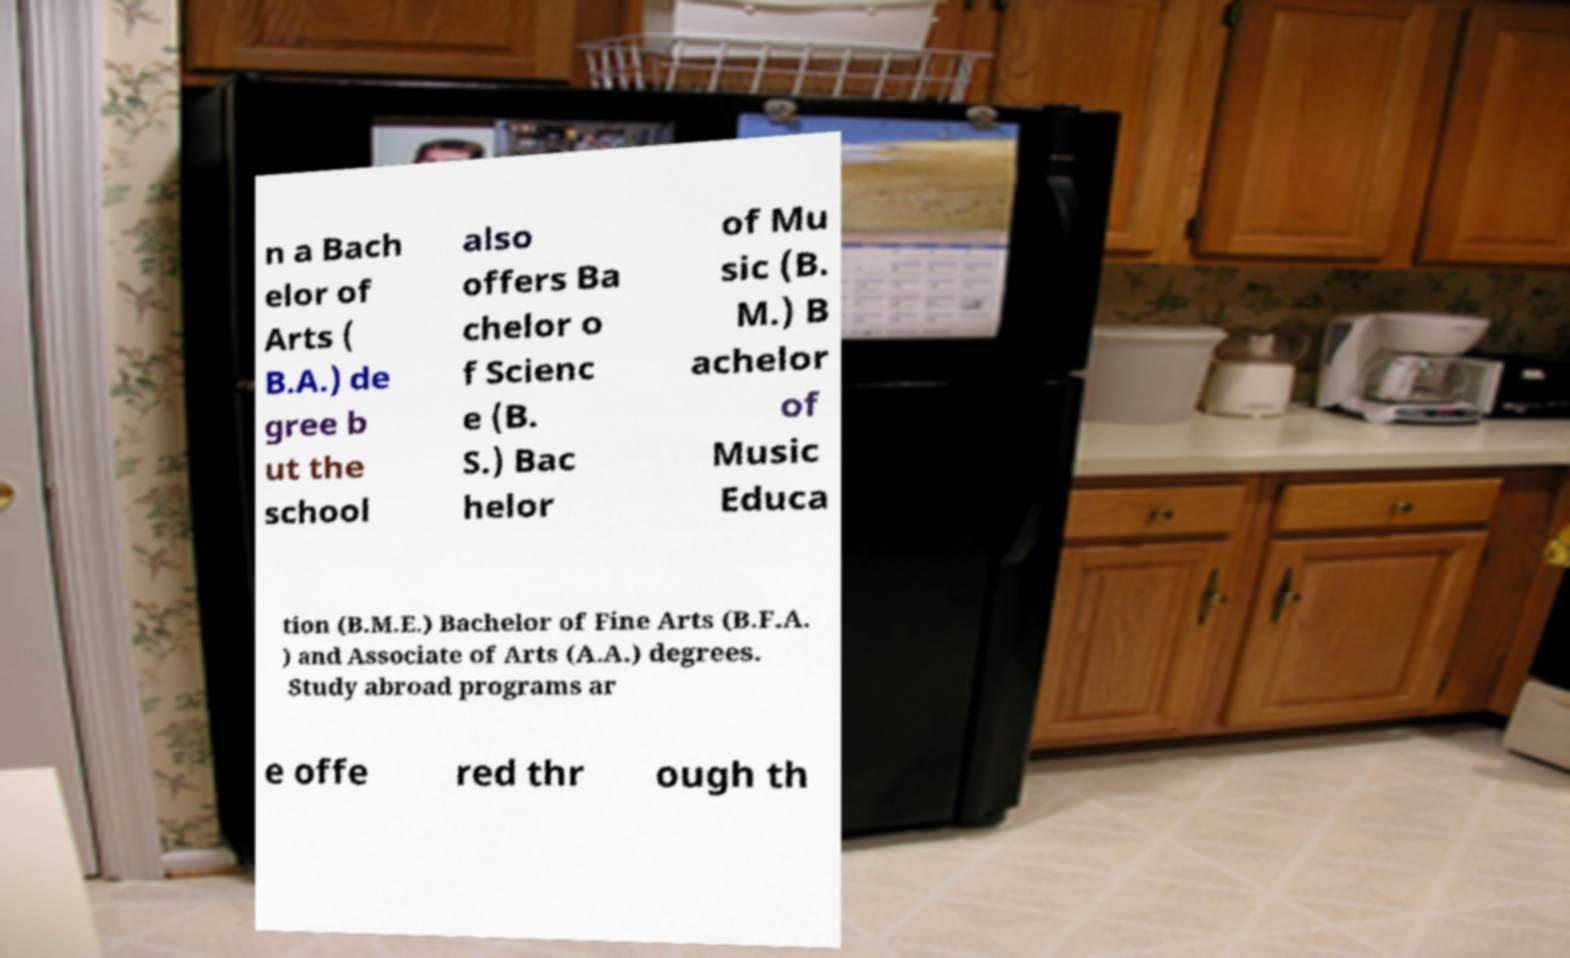Could you assist in decoding the text presented in this image and type it out clearly? n a Bach elor of Arts ( B.A.) de gree b ut the school also offers Ba chelor o f Scienc e (B. S.) Bac helor of Mu sic (B. M.) B achelor of Music Educa tion (B.M.E.) Bachelor of Fine Arts (B.F.A. ) and Associate of Arts (A.A.) degrees. Study abroad programs ar e offe red thr ough th 